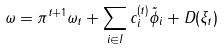Convert formula to latex. <formula><loc_0><loc_0><loc_500><loc_500>\omega = \pi ^ { t + 1 } \omega _ { t } + \sum _ { i \in I } c _ { i } ^ { ( t ) } \tilde { \phi } _ { i } + D ( \xi _ { t } )</formula> 